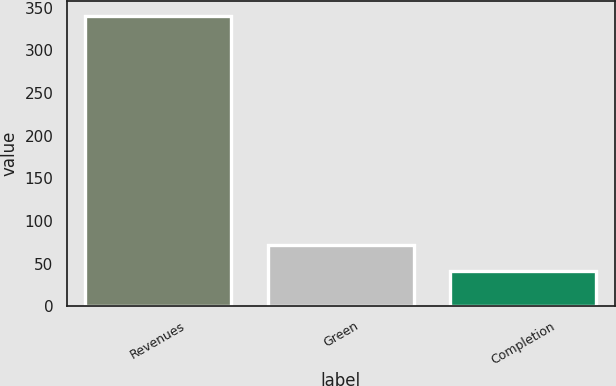Convert chart to OTSL. <chart><loc_0><loc_0><loc_500><loc_500><bar_chart><fcel>Revenues<fcel>Green<fcel>Completion<nl><fcel>341<fcel>71.9<fcel>42<nl></chart> 